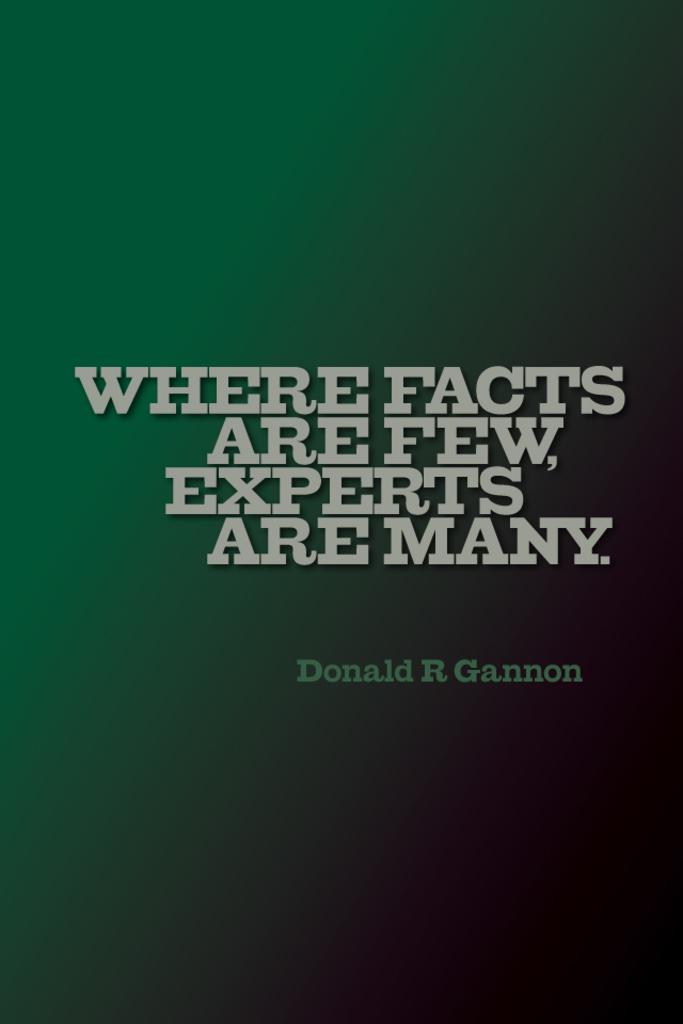<image>
Provide a brief description of the given image. The book shown was written by the author Donald R Gannon. 